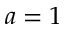<formula> <loc_0><loc_0><loc_500><loc_500>a = 1</formula> 